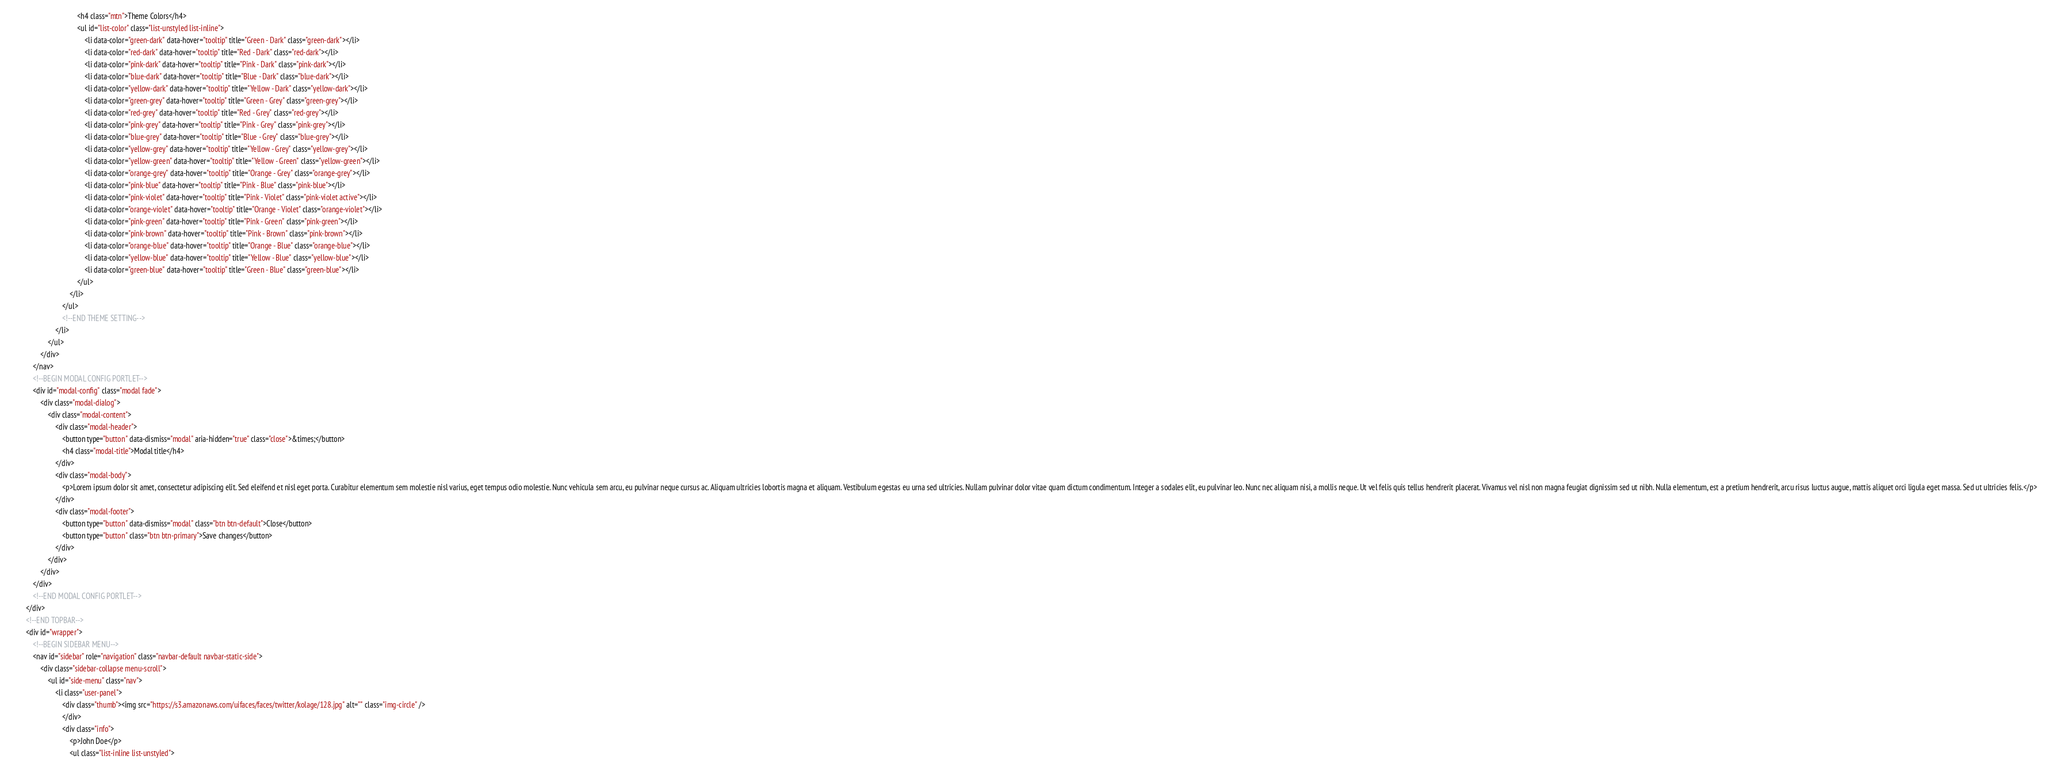<code> <loc_0><loc_0><loc_500><loc_500><_HTML_>                                    <h4 class="mtn">Theme Colors</h4>
                                    <ul id="list-color" class="list-unstyled list-inline">
                                        <li data-color="green-dark" data-hover="tooltip" title="Green - Dark" class="green-dark"></li>
                                        <li data-color="red-dark" data-hover="tooltip" title="Red - Dark" class="red-dark"></li>
                                        <li data-color="pink-dark" data-hover="tooltip" title="Pink - Dark" class="pink-dark"></li>
                                        <li data-color="blue-dark" data-hover="tooltip" title="Blue - Dark" class="blue-dark"></li>
                                        <li data-color="yellow-dark" data-hover="tooltip" title="Yellow - Dark" class="yellow-dark"></li>
                                        <li data-color="green-grey" data-hover="tooltip" title="Green - Grey" class="green-grey"></li>
                                        <li data-color="red-grey" data-hover="tooltip" title="Red - Grey" class="red-grey"></li>
                                        <li data-color="pink-grey" data-hover="tooltip" title="Pink - Grey" class="pink-grey"></li>
                                        <li data-color="blue-grey" data-hover="tooltip" title="Blue - Grey" class="blue-grey"></li>
                                        <li data-color="yellow-grey" data-hover="tooltip" title="Yellow - Grey" class="yellow-grey"></li>
                                        <li data-color="yellow-green" data-hover="tooltip" title="Yellow - Green" class="yellow-green"></li>
                                        <li data-color="orange-grey" data-hover="tooltip" title="Orange - Grey" class="orange-grey"></li>
                                        <li data-color="pink-blue" data-hover="tooltip" title="Pink - Blue" class="pink-blue"></li>
                                        <li data-color="pink-violet" data-hover="tooltip" title="Pink - Violet" class="pink-violet active"></li>
                                        <li data-color="orange-violet" data-hover="tooltip" title="Orange - Violet" class="orange-violet"></li>
                                        <li data-color="pink-green" data-hover="tooltip" title="Pink - Green" class="pink-green"></li>
                                        <li data-color="pink-brown" data-hover="tooltip" title="Pink - Brown" class="pink-brown"></li>
                                        <li data-color="orange-blue" data-hover="tooltip" title="Orange - Blue" class="orange-blue"></li>
                                        <li data-color="yellow-blue" data-hover="tooltip" title="Yellow - Blue" class="yellow-blue"></li>
                                        <li data-color="green-blue" data-hover="tooltip" title="Green - Blue" class="green-blue"></li>
                                    </ul>
                                </li>
                            </ul>
                            <!--END THEME SETTING-->
                        </li>
                    </ul>
                </div>
            </nav>
            <!--BEGIN MODAL CONFIG PORTLET-->
            <div id="modal-config" class="modal fade">
                <div class="modal-dialog">
                    <div class="modal-content">
                        <div class="modal-header">
                            <button type="button" data-dismiss="modal" aria-hidden="true" class="close">&times;</button>
                            <h4 class="modal-title">Modal title</h4>
                        </div>
                        <div class="modal-body">
                            <p>Lorem ipsum dolor sit amet, consectetur adipiscing elit. Sed eleifend et nisl eget porta. Curabitur elementum sem molestie nisl varius, eget tempus odio molestie. Nunc vehicula sem arcu, eu pulvinar neque cursus ac. Aliquam ultricies lobortis magna et aliquam. Vestibulum egestas eu urna sed ultricies. Nullam pulvinar dolor vitae quam dictum condimentum. Integer a sodales elit, eu pulvinar leo. Nunc nec aliquam nisi, a mollis neque. Ut vel felis quis tellus hendrerit placerat. Vivamus vel nisl non magna feugiat dignissim sed ut nibh. Nulla elementum, est a pretium hendrerit, arcu risus luctus augue, mattis aliquet orci ligula eget massa. Sed ut ultricies felis.</p>
                        </div>
                        <div class="modal-footer">
                            <button type="button" data-dismiss="modal" class="btn btn-default">Close</button>
                            <button type="button" class="btn btn-primary">Save changes</button>
                        </div>
                    </div>
                </div>
            </div>
            <!--END MODAL CONFIG PORTLET-->
        </div>
        <!--END TOPBAR-->
        <div id="wrapper">
            <!--BEGIN SIDEBAR MENU-->
            <nav id="sidebar" role="navigation" class="navbar-default navbar-static-side">
                <div class="sidebar-collapse menu-scroll">
                    <ul id="side-menu" class="nav">
                        <li class="user-panel">
                            <div class="thumb"><img src="https://s3.amazonaws.com/uifaces/faces/twitter/kolage/128.jpg" alt="" class="img-circle" />
                            </div>
                            <div class="info">
                                <p>John Doe</p>
                                <ul class="list-inline list-unstyled"></code> 